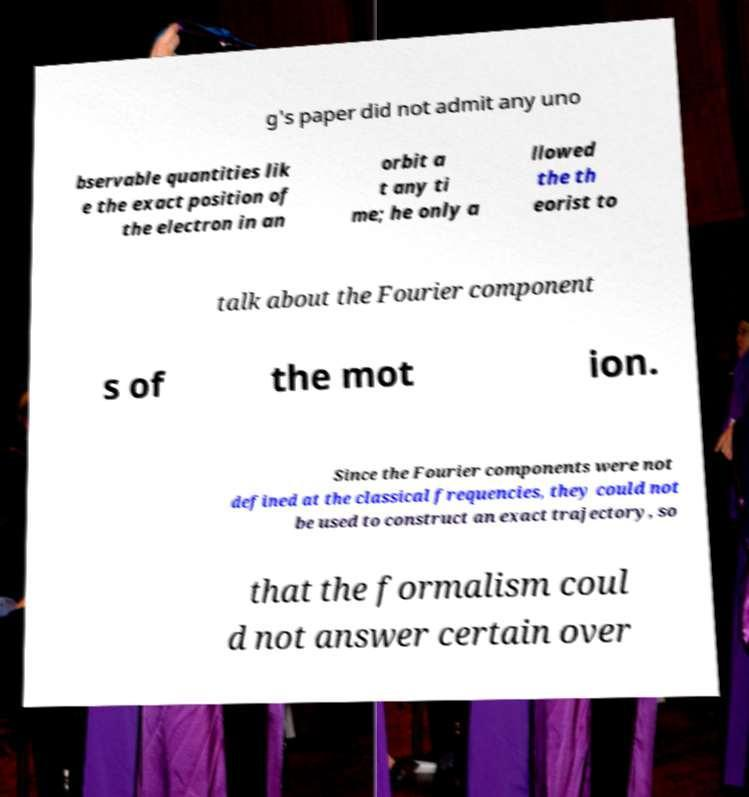There's text embedded in this image that I need extracted. Can you transcribe it verbatim? g's paper did not admit any uno bservable quantities lik e the exact position of the electron in an orbit a t any ti me; he only a llowed the th eorist to talk about the Fourier component s of the mot ion. Since the Fourier components were not defined at the classical frequencies, they could not be used to construct an exact trajectory, so that the formalism coul d not answer certain over 